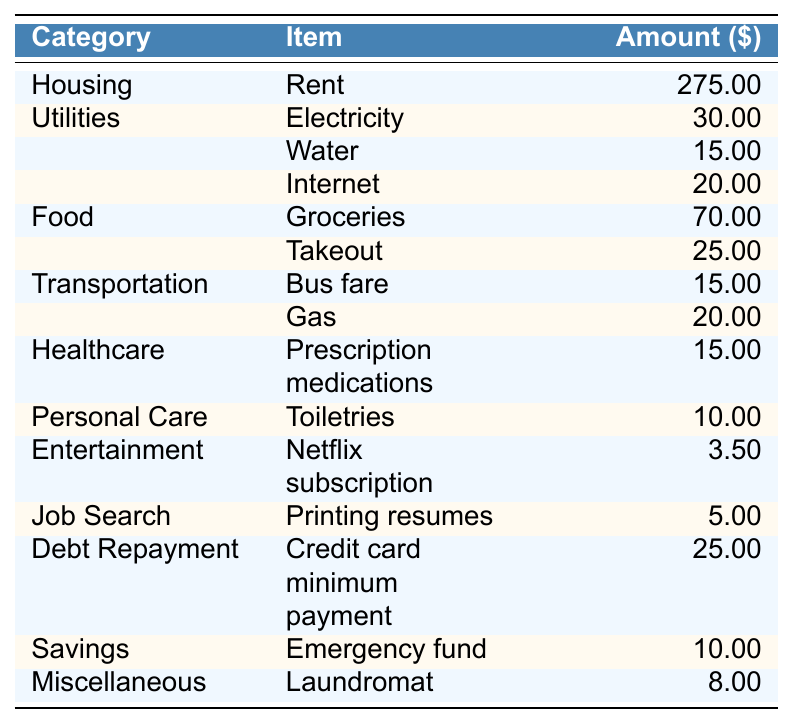What is the total amount spent on housing? The only item listed under the housing category is rent, which amounts to $275.00. Therefore, the total amount spent on housing is the rent amount itself.
Answer: 275.00 What is the total amount spent on utilities? There are three items listed under the utilities category: Electricity ($30.00), Water ($15.00), and Internet ($20.00). Adding these amounts gives us $30.00 + $15.00 + $20.00 = $65.00.
Answer: 65.00 How much do weekly groceries cost? The table lists groceries under the food category, with an amount specified as $70.00. Therefore, the weekly cost for groceries is simply the amount listed.
Answer: 70.00 Is the amount spent on entertainment greater than the amount spent on personal care? The entertainment category shows $3.50 for a Netflix subscription, while personal care shows $10.00 for toiletries. Since $3.50 is less than $10.00, the statement is false.
Answer: No What is the total spending on food? The food category has two items: Groceries ($70.00) and Takeout ($25.00). Summing these amounts gives $70.00 + $25.00 = $95.00, which is the total food spending.
Answer: 95.00 Is the spending on transportation higher than the spending on debt repayment? Transportation costs $15.00 (bus fare) + $20.00 (gas), which totals $35.00. Debt repayment is $25.00. Since $35.00 is greater than $25.00, the statement is true.
Answer: Yes What is the average amount spent on utilities per item? There are three items listed under the utilities category, totaling $65.00. To find the average, we divide the total by the number of items: $65.00 / 3 = $21.67.
Answer: 21.67 How much is spent on healthcare compared to savings? The healthcare spending is $15.00, while savings amount to $10.00. $15.00 is greater than $10.00, meaning healthcare spending exceeds savings by $5.00.
Answer: 15.00 > 10.00 What is the total weekly expense across all categories? Summing all the individual amounts from each category gives: $275.00 (Housing) + $65.00 (Utilities) + $95.00 (Food) + $35.00 (Transportation) + $15.00 (Healthcare) + $10.00 (Personal Care) + $3.50 (Entertainment) + $5.00 (Job Search) + $25.00 (Debt Repayment) + $10.00 (Savings) + $8.00 (Miscellaneous) = $573.50.
Answer: 573.50 What percentage of total expenses is allocated to housing? The total expenses are $573.50, and the amount allocated to housing (rent) is $275.00. To find the percentage, we calculate ($275.00 / $573.50) * 100 ≈ 47.94%.
Answer: 47.94% 